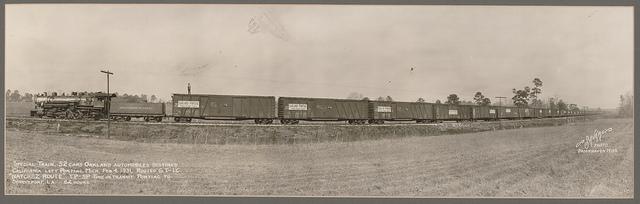What do many of the pictures have in common?
Quick response, please. Train. Is this picture from a professional?
Keep it brief. Yes. Are there any people in the photo?
Short answer required. No. What color is the grass?
Keep it brief. Brown. What type of train is depicted?
Answer briefly. Cargo. Is this a moving train?
Quick response, please. Yes. Is this picture in color?
Give a very brief answer. No. Is this in Vancouver?
Concise answer only. No. Are there passengers on this train?
Write a very short answer. No. Is this a passenger train?
Keep it brief. No. 